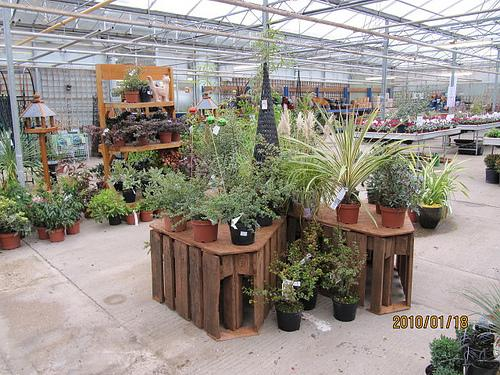What can be found here? plants 